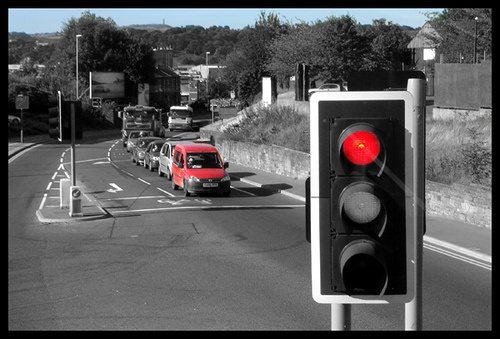Describe the objects in this image and their specific colors. I can see traffic light in black, gray, white, and red tones, truck in black, gray, salmon, and lightpink tones, car in black, gray, salmon, and lightpink tones, truck in black, gray, darkgray, and lightgray tones, and truck in black, gray, darkgray, and white tones in this image. 